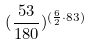<formula> <loc_0><loc_0><loc_500><loc_500>( \frac { 5 3 } { 1 8 0 } ) ^ { ( \frac { 6 } { 2 } \cdot 8 3 ) }</formula> 